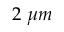<formula> <loc_0><loc_0><loc_500><loc_500>2 \mu m</formula> 